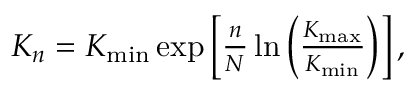Convert formula to latex. <formula><loc_0><loc_0><loc_500><loc_500>\begin{array} { r } { K _ { n } = K _ { \min } \exp \left [ \frac { n } { N } \ln \left ( \frac { K _ { \max } } { K _ { \min } } \right ) \right ] , } \end{array}</formula> 